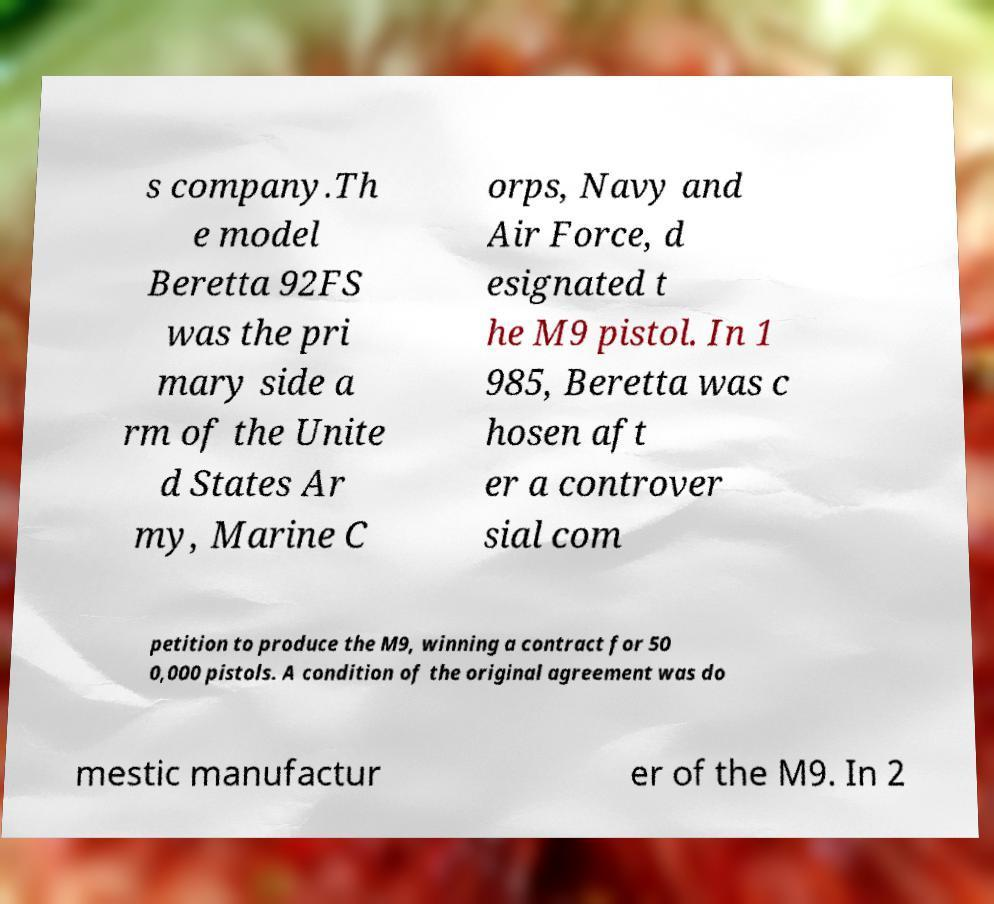There's text embedded in this image that I need extracted. Can you transcribe it verbatim? s company.Th e model Beretta 92FS was the pri mary side a rm of the Unite d States Ar my, Marine C orps, Navy and Air Force, d esignated t he M9 pistol. In 1 985, Beretta was c hosen aft er a controver sial com petition to produce the M9, winning a contract for 50 0,000 pistols. A condition of the original agreement was do mestic manufactur er of the M9. In 2 